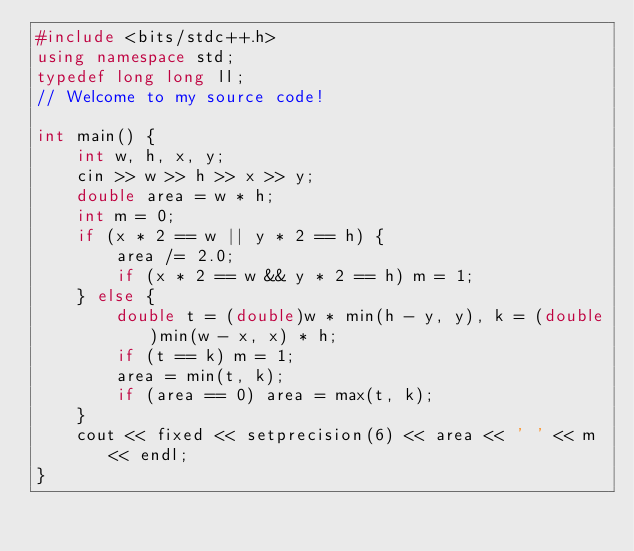<code> <loc_0><loc_0><loc_500><loc_500><_C++_>#include <bits/stdc++.h>
using namespace std;
typedef long long ll;
// Welcome to my source code!

int main() {
    int w, h, x, y;
    cin >> w >> h >> x >> y;
    double area = w * h;
    int m = 0;
    if (x * 2 == w || y * 2 == h) {
        area /= 2.0;
        if (x * 2 == w && y * 2 == h) m = 1;
    } else {
        double t = (double)w * min(h - y, y), k = (double)min(w - x, x) * h;
        if (t == k) m = 1;
        area = min(t, k);
        if (area == 0) area = max(t, k);
    }
    cout << fixed << setprecision(6) << area << ' ' << m << endl;
}</code> 